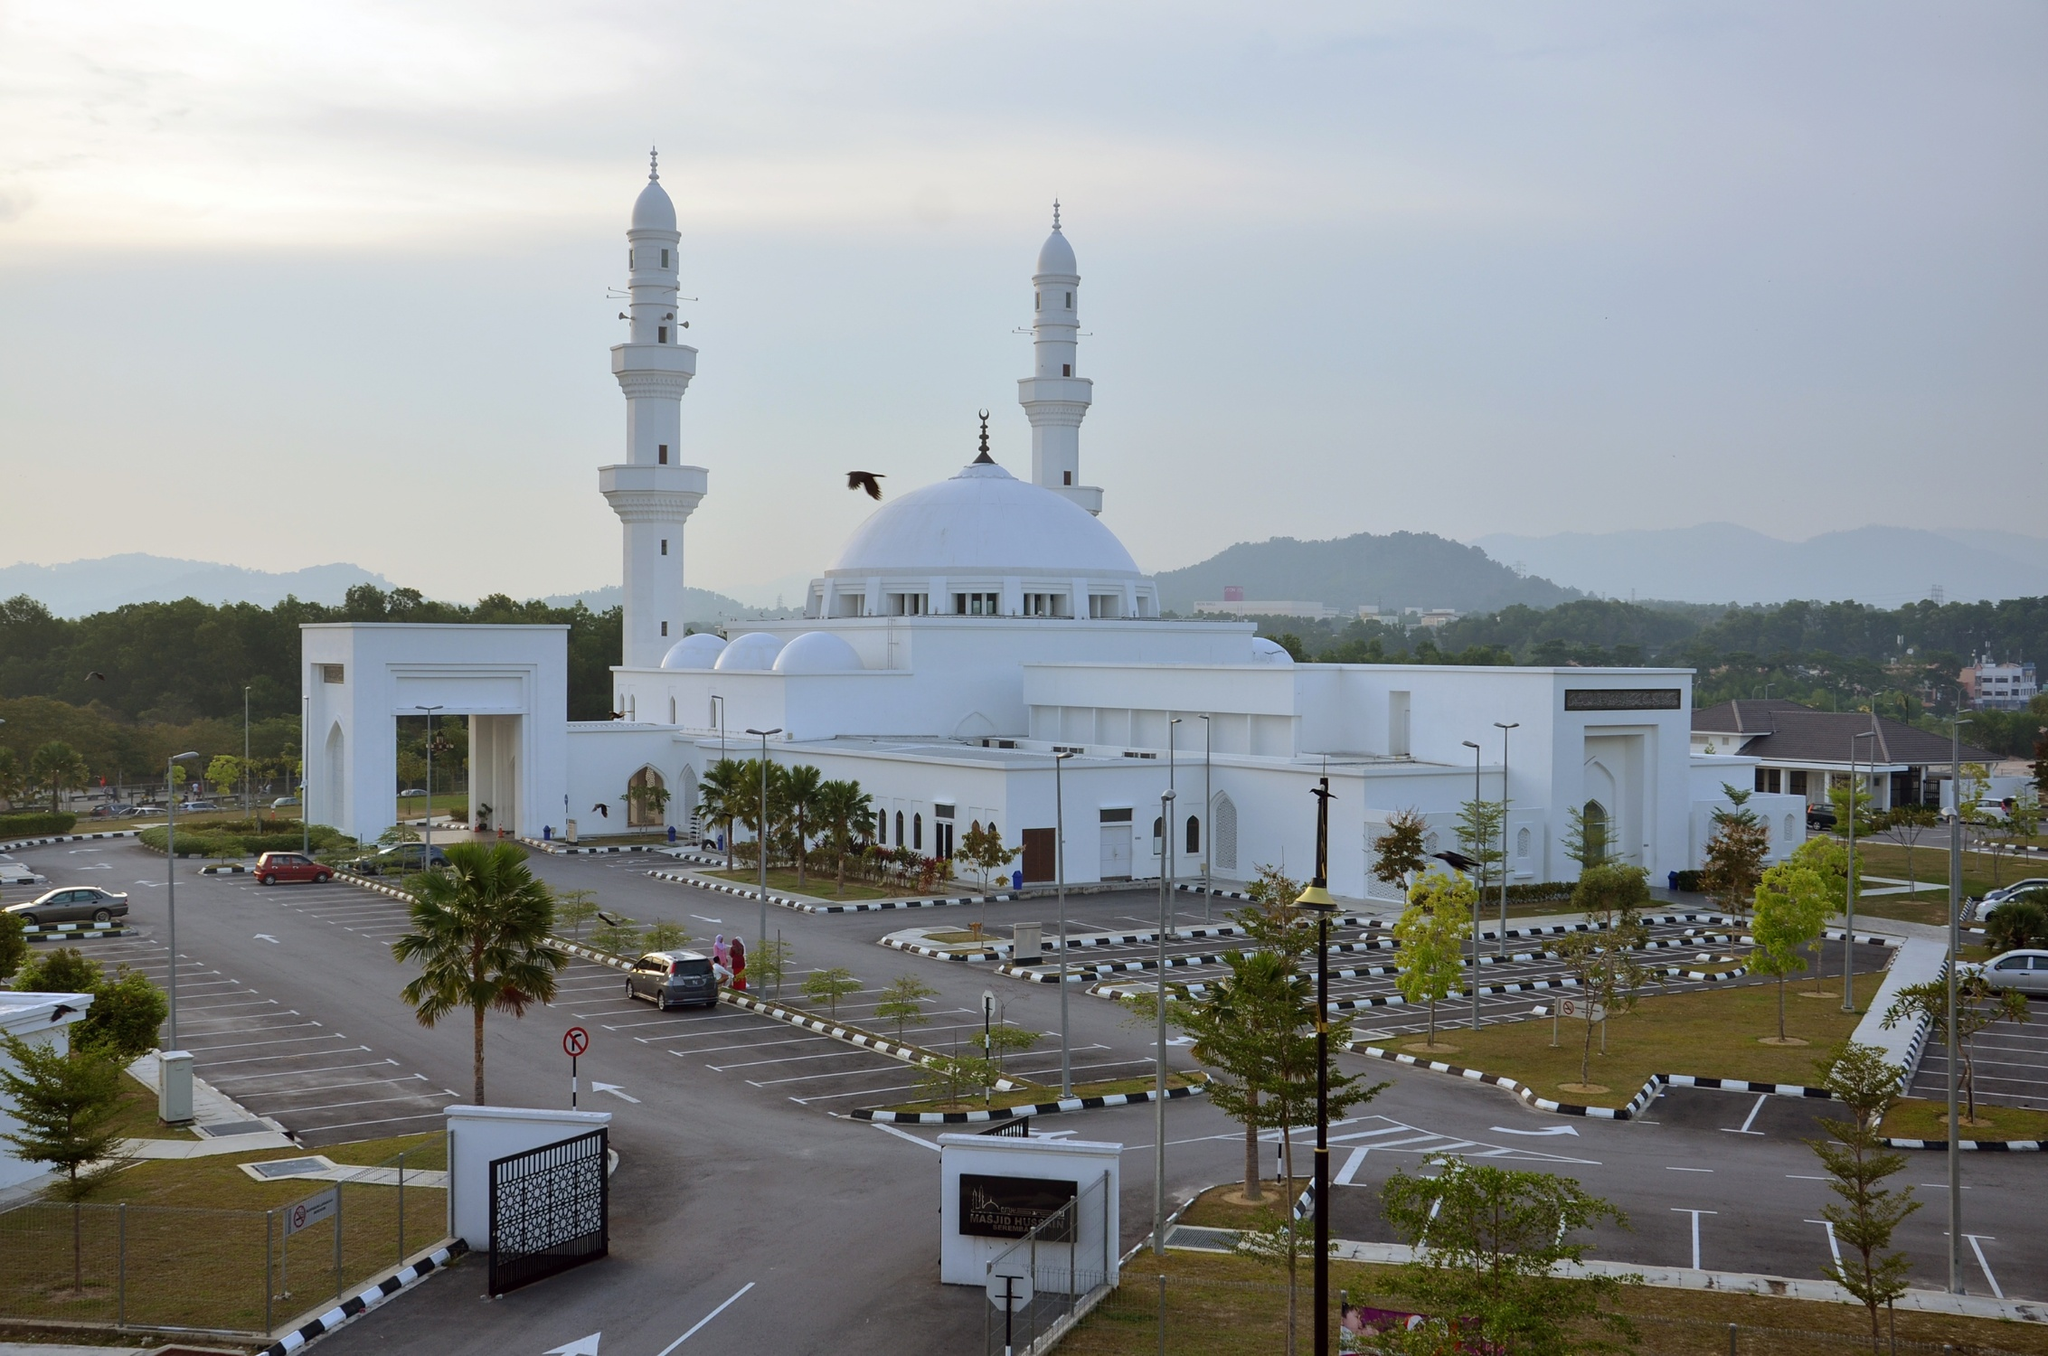Describe the following image. The image illustrates the Tengku Ampuan Jemaah Mosque, a striking architectural piece in Bukit Jelutong, Malaysia. This beautifully structured mosque features a vast white dome and two elegantly designed minarets that pierce the sky. The photograph is taken from a distance, showing the mosque's grand scale against a backdrop of a softly hued sky and distant hills. A parking lot in the foreground is partially filled, suggesting either a tranquil day or a non-peak hour. Surrounding the mosque are patches of greenery, enhancing the peaceful and sacred atmosphere typical of a place of worship. This mosque not only serves as a religious center but also stands as a beacon of cultural pride within the community. 